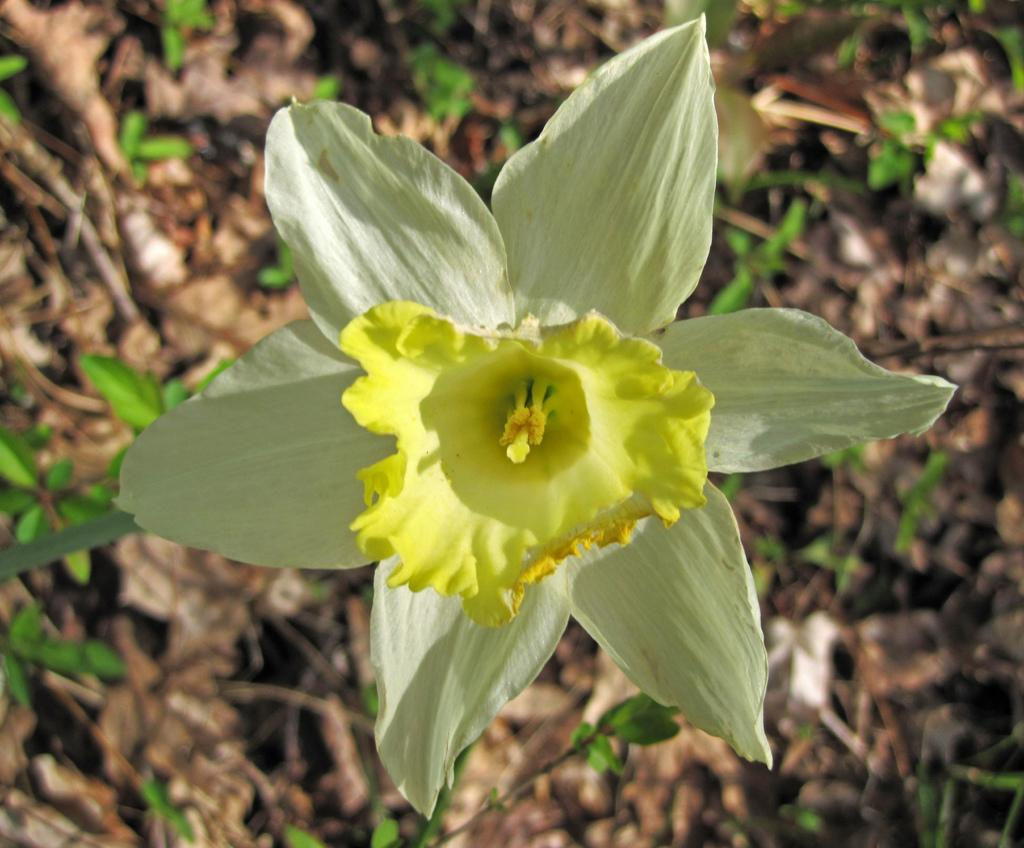What type of plant can be seen in the image? There is a flower in the image. Are there any other plants visible in the image? Yes, there are plants in the image. What is the condition of the leaves in the image? Shredded leaves are visible in the image. Where is the father standing in the image? There is no father present in the image; it only features plants and flowers. What type of mailbox can be seen in the image? There is no mailbox present in the image; it only features plants and flowers. 